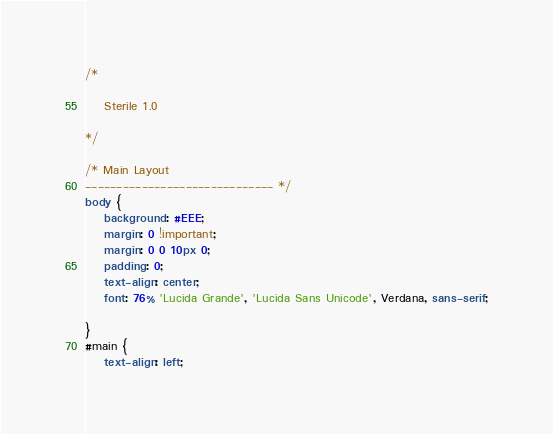<code> <loc_0><loc_0><loc_500><loc_500><_CSS_>/*

	Sterile 1.0

*/

/* Main Layout
------------------------------ */
body {
	background: #EEE;
	margin: 0 !important;
	margin: 0 0 10px 0;
	padding: 0;
	text-align: center;
	font: 76% 'Lucida Grande', 'Lucida Sans Unicode', Verdana, sans-serif;

}
#main {
	text-align: left;</code> 